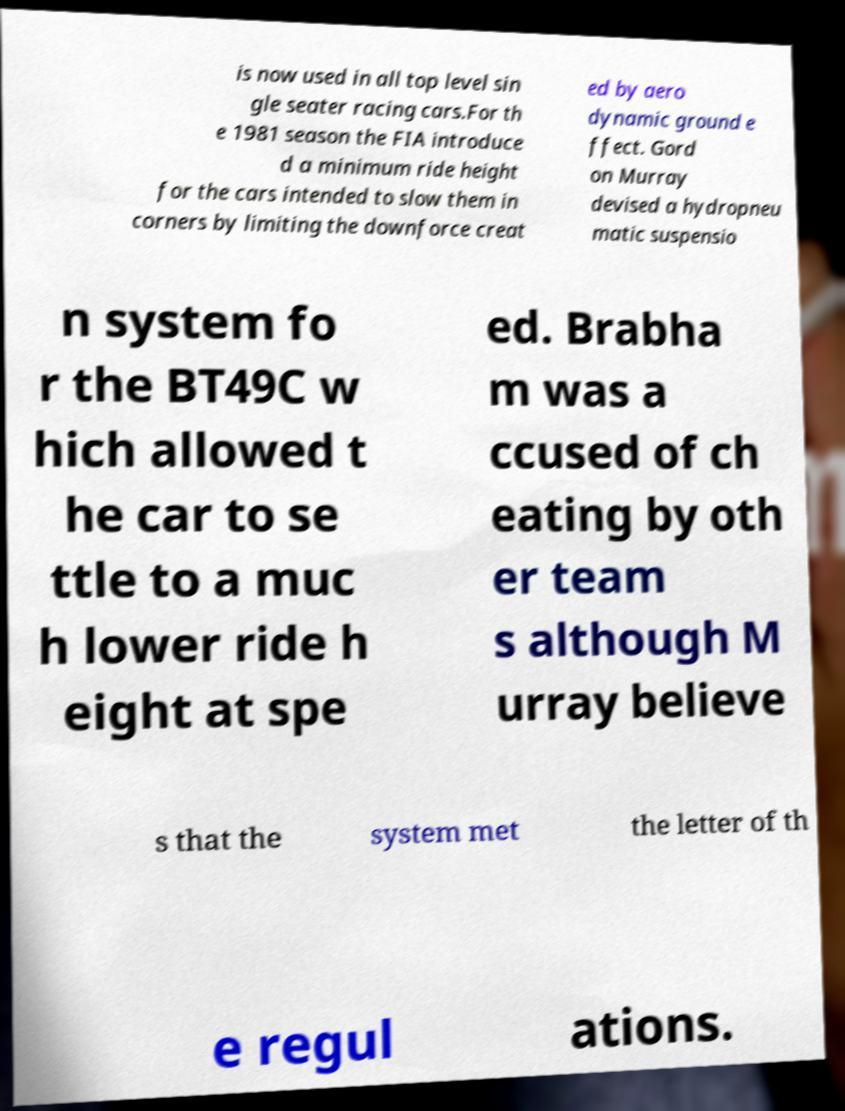Can you read and provide the text displayed in the image?This photo seems to have some interesting text. Can you extract and type it out for me? is now used in all top level sin gle seater racing cars.For th e 1981 season the FIA introduce d a minimum ride height for the cars intended to slow them in corners by limiting the downforce creat ed by aero dynamic ground e ffect. Gord on Murray devised a hydropneu matic suspensio n system fo r the BT49C w hich allowed t he car to se ttle to a muc h lower ride h eight at spe ed. Brabha m was a ccused of ch eating by oth er team s although M urray believe s that the system met the letter of th e regul ations. 